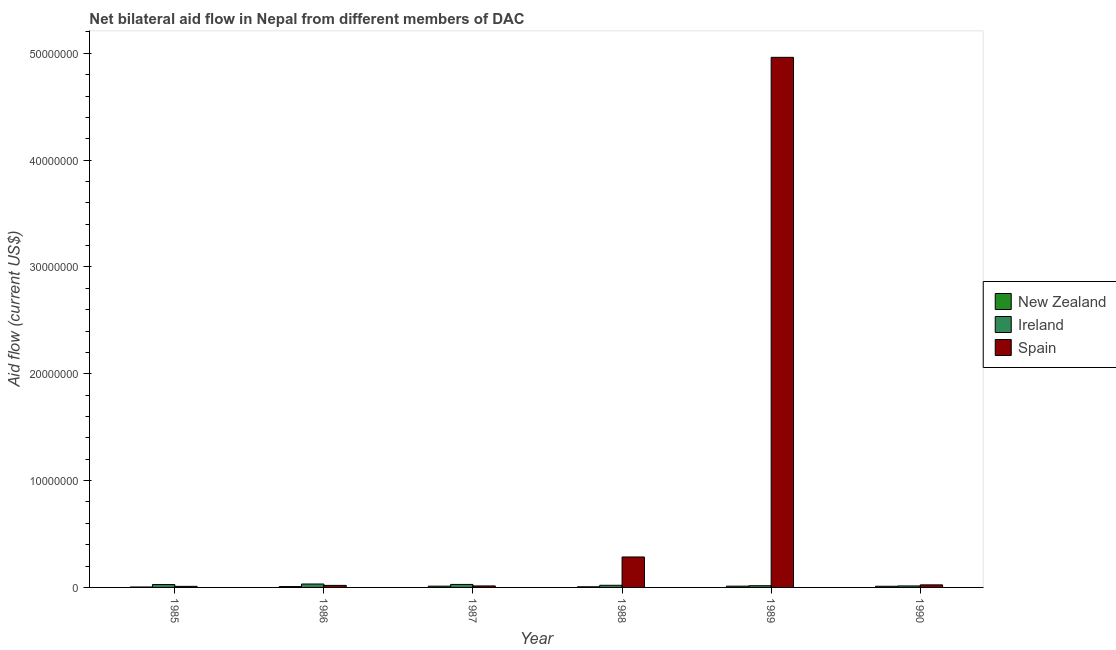Are the number of bars per tick equal to the number of legend labels?
Provide a short and direct response. Yes. Are the number of bars on each tick of the X-axis equal?
Your answer should be very brief. Yes. What is the amount of aid provided by spain in 1988?
Your answer should be very brief. 2.85e+06. Across all years, what is the maximum amount of aid provided by ireland?
Keep it short and to the point. 3.20e+05. Across all years, what is the minimum amount of aid provided by spain?
Ensure brevity in your answer.  1.00e+05. In which year was the amount of aid provided by spain minimum?
Give a very brief answer. 1985. What is the total amount of aid provided by ireland in the graph?
Your response must be concise. 1.37e+06. What is the difference between the amount of aid provided by spain in 1986 and that in 1990?
Your answer should be very brief. -5.00e+04. What is the difference between the amount of aid provided by new zealand in 1988 and the amount of aid provided by spain in 1987?
Offer a terse response. -6.00e+04. What is the average amount of aid provided by spain per year?
Your answer should be very brief. 8.86e+06. Is the difference between the amount of aid provided by new zealand in 1987 and 1989 greater than the difference between the amount of aid provided by ireland in 1987 and 1989?
Offer a terse response. No. What is the difference between the highest and the lowest amount of aid provided by new zealand?
Ensure brevity in your answer.  8.00e+04. In how many years, is the amount of aid provided by new zealand greater than the average amount of aid provided by new zealand taken over all years?
Give a very brief answer. 3. What does the 2nd bar from the left in 1989 represents?
Provide a short and direct response. Ireland. What does the 3rd bar from the right in 1989 represents?
Provide a succinct answer. New Zealand. Is it the case that in every year, the sum of the amount of aid provided by new zealand and amount of aid provided by ireland is greater than the amount of aid provided by spain?
Keep it short and to the point. No. How many bars are there?
Your response must be concise. 18. Are all the bars in the graph horizontal?
Your answer should be compact. No. How many years are there in the graph?
Provide a short and direct response. 6. What is the difference between two consecutive major ticks on the Y-axis?
Make the answer very short. 1.00e+07. What is the title of the graph?
Your answer should be very brief. Net bilateral aid flow in Nepal from different members of DAC. What is the label or title of the Y-axis?
Provide a succinct answer. Aid flow (current US$). What is the Aid flow (current US$) of Spain in 1985?
Make the answer very short. 1.00e+05. What is the Aid flow (current US$) in New Zealand in 1986?
Offer a terse response. 8.00e+04. What is the Aid flow (current US$) in Spain in 1986?
Provide a succinct answer. 1.90e+05. What is the Aid flow (current US$) of New Zealand in 1988?
Your answer should be compact. 6.00e+04. What is the Aid flow (current US$) in Spain in 1988?
Your answer should be very brief. 2.85e+06. What is the Aid flow (current US$) of Ireland in 1989?
Make the answer very short. 1.60e+05. What is the Aid flow (current US$) of Spain in 1989?
Your response must be concise. 4.96e+07. What is the Aid flow (current US$) in Spain in 1990?
Ensure brevity in your answer.  2.40e+05. Across all years, what is the maximum Aid flow (current US$) of New Zealand?
Ensure brevity in your answer.  1.20e+05. Across all years, what is the maximum Aid flow (current US$) of Ireland?
Your response must be concise. 3.20e+05. Across all years, what is the maximum Aid flow (current US$) in Spain?
Make the answer very short. 4.96e+07. Across all years, what is the minimum Aid flow (current US$) in New Zealand?
Ensure brevity in your answer.  4.00e+04. Across all years, what is the minimum Aid flow (current US$) of Ireland?
Make the answer very short. 1.40e+05. What is the total Aid flow (current US$) of New Zealand in the graph?
Your answer should be very brief. 5.30e+05. What is the total Aid flow (current US$) in Ireland in the graph?
Ensure brevity in your answer.  1.37e+06. What is the total Aid flow (current US$) of Spain in the graph?
Ensure brevity in your answer.  5.31e+07. What is the difference between the Aid flow (current US$) of Spain in 1985 and that in 1986?
Provide a short and direct response. -9.00e+04. What is the difference between the Aid flow (current US$) of New Zealand in 1985 and that in 1987?
Your answer should be very brief. -8.00e+04. What is the difference between the Aid flow (current US$) in New Zealand in 1985 and that in 1988?
Give a very brief answer. -2.00e+04. What is the difference between the Aid flow (current US$) in Spain in 1985 and that in 1988?
Offer a terse response. -2.75e+06. What is the difference between the Aid flow (current US$) of New Zealand in 1985 and that in 1989?
Your response must be concise. -8.00e+04. What is the difference between the Aid flow (current US$) of Spain in 1985 and that in 1989?
Provide a succinct answer. -4.95e+07. What is the difference between the Aid flow (current US$) of New Zealand in 1985 and that in 1990?
Give a very brief answer. -7.00e+04. What is the difference between the Aid flow (current US$) in New Zealand in 1986 and that in 1987?
Offer a terse response. -4.00e+04. What is the difference between the Aid flow (current US$) of New Zealand in 1986 and that in 1988?
Your answer should be very brief. 2.00e+04. What is the difference between the Aid flow (current US$) in Ireland in 1986 and that in 1988?
Your response must be concise. 1.20e+05. What is the difference between the Aid flow (current US$) in Spain in 1986 and that in 1988?
Make the answer very short. -2.66e+06. What is the difference between the Aid flow (current US$) in Ireland in 1986 and that in 1989?
Provide a short and direct response. 1.60e+05. What is the difference between the Aid flow (current US$) of Spain in 1986 and that in 1989?
Provide a short and direct response. -4.94e+07. What is the difference between the Aid flow (current US$) in Spain in 1987 and that in 1988?
Your response must be concise. -2.71e+06. What is the difference between the Aid flow (current US$) in Spain in 1987 and that in 1989?
Your response must be concise. -4.95e+07. What is the difference between the Aid flow (current US$) of Ireland in 1987 and that in 1990?
Provide a short and direct response. 1.40e+05. What is the difference between the Aid flow (current US$) in Spain in 1987 and that in 1990?
Offer a terse response. -1.00e+05. What is the difference between the Aid flow (current US$) of New Zealand in 1988 and that in 1989?
Make the answer very short. -6.00e+04. What is the difference between the Aid flow (current US$) of Ireland in 1988 and that in 1989?
Your answer should be compact. 4.00e+04. What is the difference between the Aid flow (current US$) of Spain in 1988 and that in 1989?
Provide a succinct answer. -4.68e+07. What is the difference between the Aid flow (current US$) in New Zealand in 1988 and that in 1990?
Make the answer very short. -5.00e+04. What is the difference between the Aid flow (current US$) in Spain in 1988 and that in 1990?
Make the answer very short. 2.61e+06. What is the difference between the Aid flow (current US$) in Ireland in 1989 and that in 1990?
Your answer should be compact. 2.00e+04. What is the difference between the Aid flow (current US$) of Spain in 1989 and that in 1990?
Offer a terse response. 4.94e+07. What is the difference between the Aid flow (current US$) in New Zealand in 1985 and the Aid flow (current US$) in Ireland in 1986?
Provide a short and direct response. -2.80e+05. What is the difference between the Aid flow (current US$) of New Zealand in 1985 and the Aid flow (current US$) of Ireland in 1987?
Ensure brevity in your answer.  -2.40e+05. What is the difference between the Aid flow (current US$) of New Zealand in 1985 and the Aid flow (current US$) of Ireland in 1988?
Offer a terse response. -1.60e+05. What is the difference between the Aid flow (current US$) in New Zealand in 1985 and the Aid flow (current US$) in Spain in 1988?
Make the answer very short. -2.81e+06. What is the difference between the Aid flow (current US$) in Ireland in 1985 and the Aid flow (current US$) in Spain in 1988?
Provide a short and direct response. -2.58e+06. What is the difference between the Aid flow (current US$) in New Zealand in 1985 and the Aid flow (current US$) in Spain in 1989?
Ensure brevity in your answer.  -4.96e+07. What is the difference between the Aid flow (current US$) in Ireland in 1985 and the Aid flow (current US$) in Spain in 1989?
Your answer should be compact. -4.94e+07. What is the difference between the Aid flow (current US$) of Ireland in 1985 and the Aid flow (current US$) of Spain in 1990?
Keep it short and to the point. 3.00e+04. What is the difference between the Aid flow (current US$) in New Zealand in 1986 and the Aid flow (current US$) in Spain in 1987?
Make the answer very short. -6.00e+04. What is the difference between the Aid flow (current US$) of New Zealand in 1986 and the Aid flow (current US$) of Ireland in 1988?
Your answer should be very brief. -1.20e+05. What is the difference between the Aid flow (current US$) in New Zealand in 1986 and the Aid flow (current US$) in Spain in 1988?
Keep it short and to the point. -2.77e+06. What is the difference between the Aid flow (current US$) of Ireland in 1986 and the Aid flow (current US$) of Spain in 1988?
Make the answer very short. -2.53e+06. What is the difference between the Aid flow (current US$) of New Zealand in 1986 and the Aid flow (current US$) of Ireland in 1989?
Provide a short and direct response. -8.00e+04. What is the difference between the Aid flow (current US$) in New Zealand in 1986 and the Aid flow (current US$) in Spain in 1989?
Your response must be concise. -4.95e+07. What is the difference between the Aid flow (current US$) of Ireland in 1986 and the Aid flow (current US$) of Spain in 1989?
Make the answer very short. -4.93e+07. What is the difference between the Aid flow (current US$) of New Zealand in 1986 and the Aid flow (current US$) of Ireland in 1990?
Provide a succinct answer. -6.00e+04. What is the difference between the Aid flow (current US$) of New Zealand in 1986 and the Aid flow (current US$) of Spain in 1990?
Keep it short and to the point. -1.60e+05. What is the difference between the Aid flow (current US$) of New Zealand in 1987 and the Aid flow (current US$) of Spain in 1988?
Your response must be concise. -2.73e+06. What is the difference between the Aid flow (current US$) of Ireland in 1987 and the Aid flow (current US$) of Spain in 1988?
Your response must be concise. -2.57e+06. What is the difference between the Aid flow (current US$) in New Zealand in 1987 and the Aid flow (current US$) in Ireland in 1989?
Offer a very short reply. -4.00e+04. What is the difference between the Aid flow (current US$) of New Zealand in 1987 and the Aid flow (current US$) of Spain in 1989?
Give a very brief answer. -4.95e+07. What is the difference between the Aid flow (current US$) in Ireland in 1987 and the Aid flow (current US$) in Spain in 1989?
Offer a terse response. -4.93e+07. What is the difference between the Aid flow (current US$) of New Zealand in 1987 and the Aid flow (current US$) of Ireland in 1990?
Give a very brief answer. -2.00e+04. What is the difference between the Aid flow (current US$) in New Zealand in 1987 and the Aid flow (current US$) in Spain in 1990?
Offer a very short reply. -1.20e+05. What is the difference between the Aid flow (current US$) of New Zealand in 1988 and the Aid flow (current US$) of Spain in 1989?
Provide a short and direct response. -4.96e+07. What is the difference between the Aid flow (current US$) of Ireland in 1988 and the Aid flow (current US$) of Spain in 1989?
Provide a succinct answer. -4.94e+07. What is the average Aid flow (current US$) in New Zealand per year?
Give a very brief answer. 8.83e+04. What is the average Aid flow (current US$) in Ireland per year?
Provide a short and direct response. 2.28e+05. What is the average Aid flow (current US$) in Spain per year?
Offer a terse response. 8.86e+06. In the year 1985, what is the difference between the Aid flow (current US$) of New Zealand and Aid flow (current US$) of Ireland?
Offer a very short reply. -2.30e+05. In the year 1986, what is the difference between the Aid flow (current US$) in New Zealand and Aid flow (current US$) in Ireland?
Your answer should be very brief. -2.40e+05. In the year 1986, what is the difference between the Aid flow (current US$) in Ireland and Aid flow (current US$) in Spain?
Offer a terse response. 1.30e+05. In the year 1987, what is the difference between the Aid flow (current US$) of New Zealand and Aid flow (current US$) of Spain?
Your answer should be compact. -2.00e+04. In the year 1987, what is the difference between the Aid flow (current US$) in Ireland and Aid flow (current US$) in Spain?
Your response must be concise. 1.40e+05. In the year 1988, what is the difference between the Aid flow (current US$) of New Zealand and Aid flow (current US$) of Spain?
Ensure brevity in your answer.  -2.79e+06. In the year 1988, what is the difference between the Aid flow (current US$) of Ireland and Aid flow (current US$) of Spain?
Provide a succinct answer. -2.65e+06. In the year 1989, what is the difference between the Aid flow (current US$) of New Zealand and Aid flow (current US$) of Spain?
Ensure brevity in your answer.  -4.95e+07. In the year 1989, what is the difference between the Aid flow (current US$) of Ireland and Aid flow (current US$) of Spain?
Provide a succinct answer. -4.95e+07. In the year 1990, what is the difference between the Aid flow (current US$) in New Zealand and Aid flow (current US$) in Ireland?
Your answer should be very brief. -3.00e+04. In the year 1990, what is the difference between the Aid flow (current US$) of Ireland and Aid flow (current US$) of Spain?
Offer a terse response. -1.00e+05. What is the ratio of the Aid flow (current US$) in Ireland in 1985 to that in 1986?
Offer a terse response. 0.84. What is the ratio of the Aid flow (current US$) in Spain in 1985 to that in 1986?
Offer a terse response. 0.53. What is the ratio of the Aid flow (current US$) of New Zealand in 1985 to that in 1987?
Your answer should be very brief. 0.33. What is the ratio of the Aid flow (current US$) in Ireland in 1985 to that in 1988?
Provide a short and direct response. 1.35. What is the ratio of the Aid flow (current US$) in Spain in 1985 to that in 1988?
Your response must be concise. 0.04. What is the ratio of the Aid flow (current US$) in Ireland in 1985 to that in 1989?
Provide a succinct answer. 1.69. What is the ratio of the Aid flow (current US$) of Spain in 1985 to that in 1989?
Offer a very short reply. 0. What is the ratio of the Aid flow (current US$) of New Zealand in 1985 to that in 1990?
Offer a very short reply. 0.36. What is the ratio of the Aid flow (current US$) in Ireland in 1985 to that in 1990?
Make the answer very short. 1.93. What is the ratio of the Aid flow (current US$) of Spain in 1985 to that in 1990?
Provide a succinct answer. 0.42. What is the ratio of the Aid flow (current US$) of New Zealand in 1986 to that in 1987?
Your answer should be compact. 0.67. What is the ratio of the Aid flow (current US$) of Spain in 1986 to that in 1987?
Provide a short and direct response. 1.36. What is the ratio of the Aid flow (current US$) in Spain in 1986 to that in 1988?
Your answer should be very brief. 0.07. What is the ratio of the Aid flow (current US$) of Ireland in 1986 to that in 1989?
Your response must be concise. 2. What is the ratio of the Aid flow (current US$) in Spain in 1986 to that in 1989?
Make the answer very short. 0. What is the ratio of the Aid flow (current US$) of New Zealand in 1986 to that in 1990?
Your response must be concise. 0.73. What is the ratio of the Aid flow (current US$) of Ireland in 1986 to that in 1990?
Provide a succinct answer. 2.29. What is the ratio of the Aid flow (current US$) of Spain in 1986 to that in 1990?
Your answer should be very brief. 0.79. What is the ratio of the Aid flow (current US$) of New Zealand in 1987 to that in 1988?
Your answer should be compact. 2. What is the ratio of the Aid flow (current US$) in Ireland in 1987 to that in 1988?
Make the answer very short. 1.4. What is the ratio of the Aid flow (current US$) of Spain in 1987 to that in 1988?
Your response must be concise. 0.05. What is the ratio of the Aid flow (current US$) in Ireland in 1987 to that in 1989?
Your answer should be very brief. 1.75. What is the ratio of the Aid flow (current US$) of Spain in 1987 to that in 1989?
Give a very brief answer. 0. What is the ratio of the Aid flow (current US$) in New Zealand in 1987 to that in 1990?
Offer a terse response. 1.09. What is the ratio of the Aid flow (current US$) of Spain in 1987 to that in 1990?
Give a very brief answer. 0.58. What is the ratio of the Aid flow (current US$) of Spain in 1988 to that in 1989?
Offer a terse response. 0.06. What is the ratio of the Aid flow (current US$) in New Zealand in 1988 to that in 1990?
Your response must be concise. 0.55. What is the ratio of the Aid flow (current US$) of Ireland in 1988 to that in 1990?
Your response must be concise. 1.43. What is the ratio of the Aid flow (current US$) of Spain in 1988 to that in 1990?
Your response must be concise. 11.88. What is the ratio of the Aid flow (current US$) of Spain in 1989 to that in 1990?
Provide a succinct answer. 206.75. What is the difference between the highest and the second highest Aid flow (current US$) of New Zealand?
Provide a short and direct response. 0. What is the difference between the highest and the second highest Aid flow (current US$) of Spain?
Your response must be concise. 4.68e+07. What is the difference between the highest and the lowest Aid flow (current US$) in Spain?
Offer a terse response. 4.95e+07. 